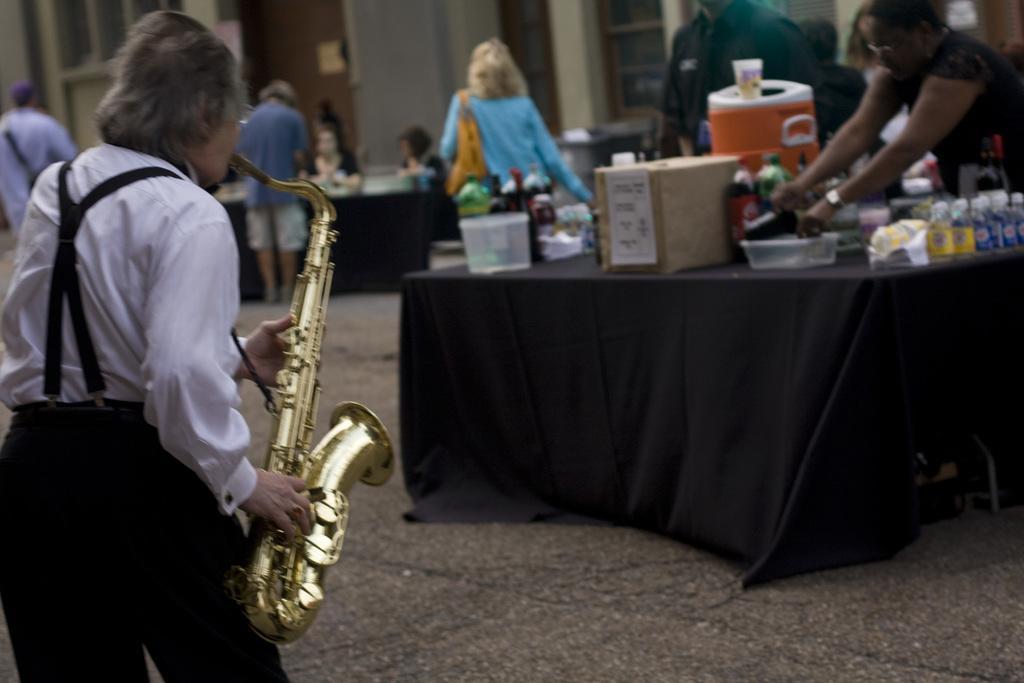Please provide a concise description of this image. In this image a person wearing a white shirt is holding a saxophone. Right side there is a table having a box, few bottles, basket and few objects are on it. Behind there are few persons standing. A woman wearing a blue top is carrying a bag. Beside there is a table having few person sitting behind it. A person wearing a blue shirt is standing before the table. Background there is a wall having few doors and windows. 